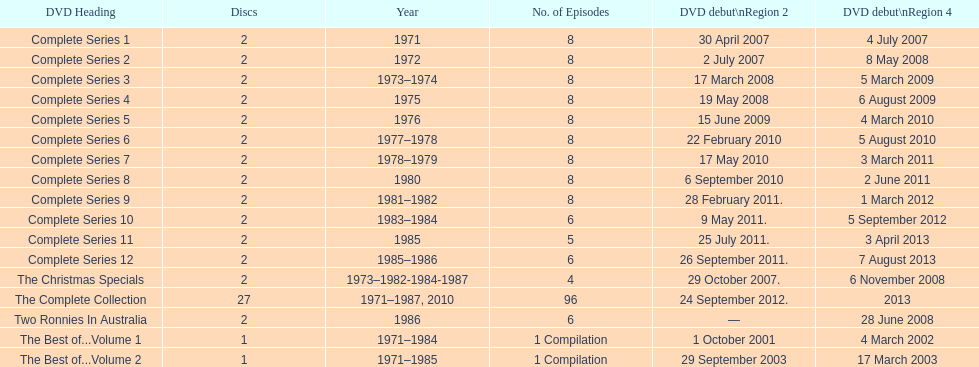What is the total of all dics listed in the table? 57. 